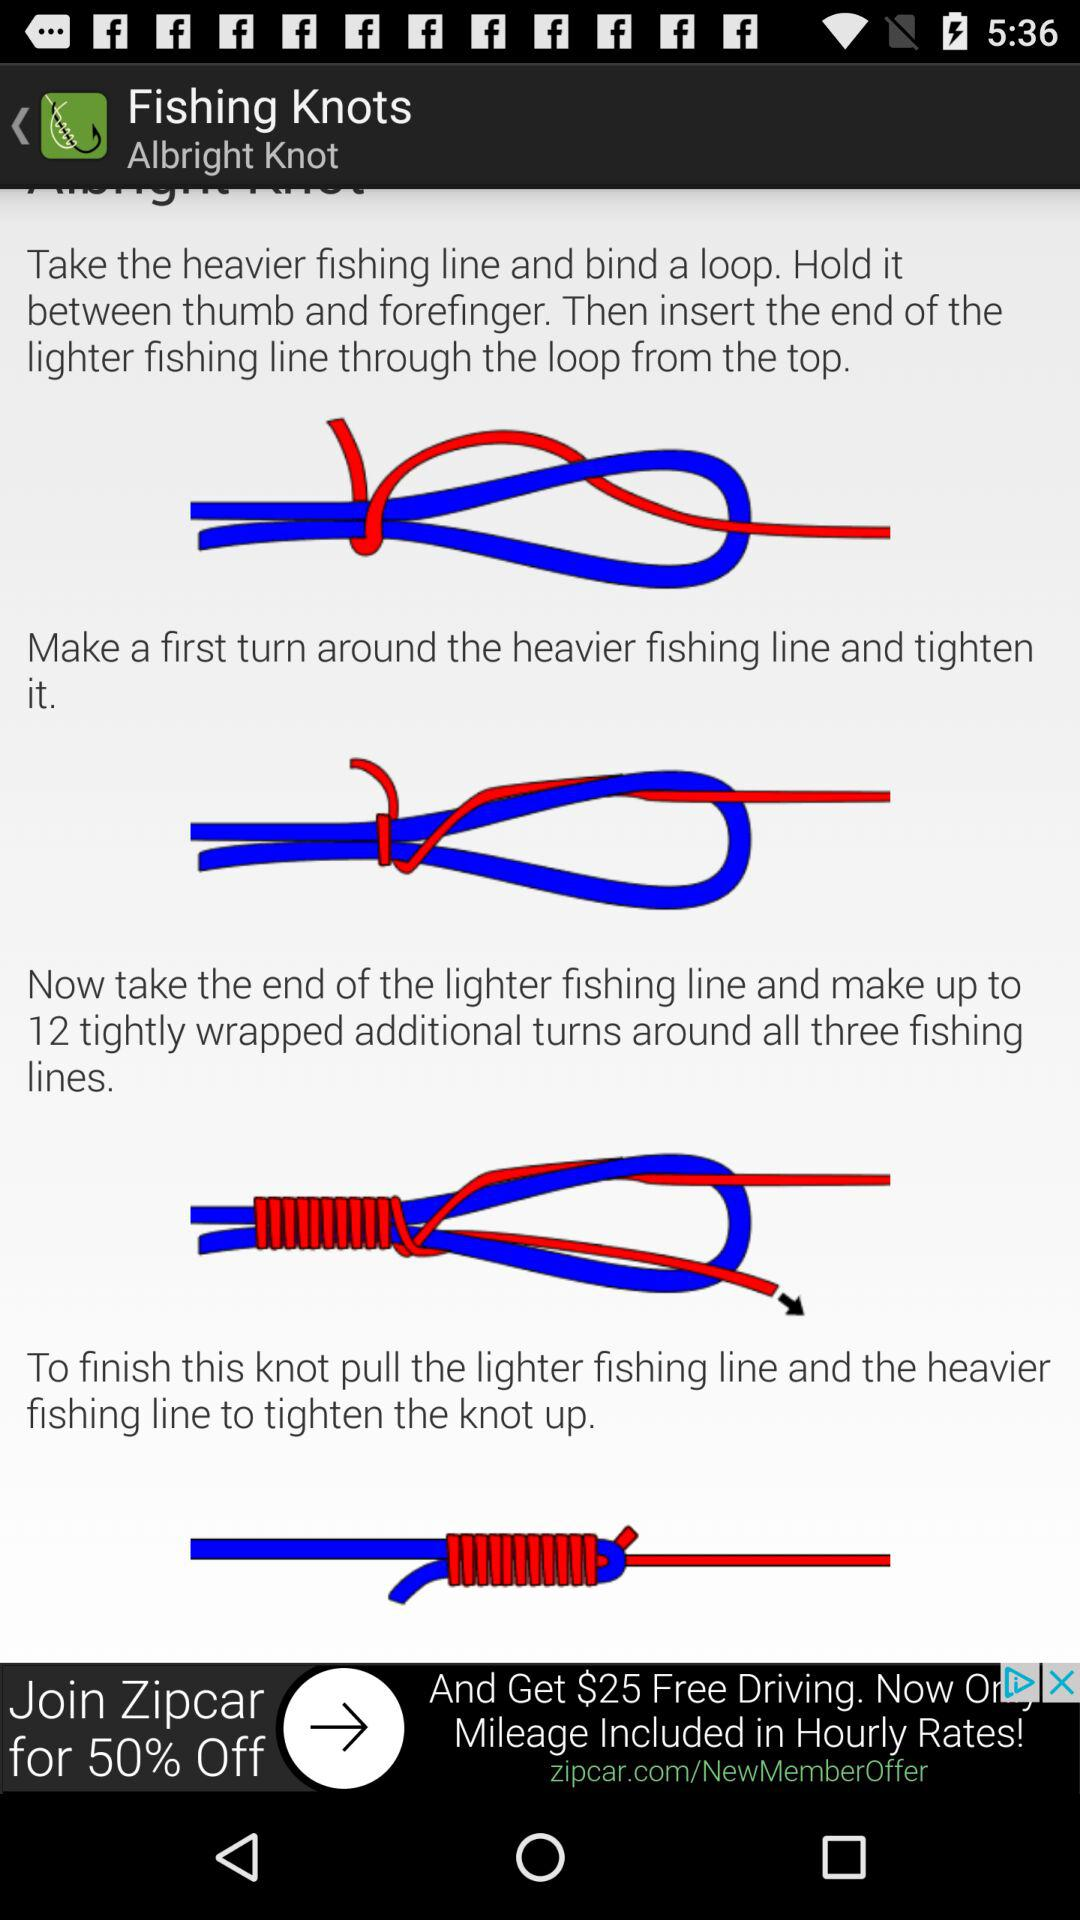How many tightly wrapped additional turns were made around all three fishing lines? There were 12 tightly wrapped additional turns around all three fishing lines. 